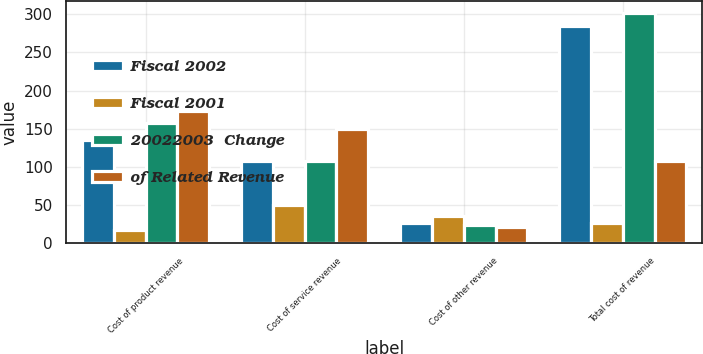Convert chart. <chart><loc_0><loc_0><loc_500><loc_500><stacked_bar_chart><ecel><fcel>Cost of product revenue<fcel>Cost of service revenue<fcel>Cost of other revenue<fcel>Total cost of revenue<nl><fcel>Fiscal 2002<fcel>135.6<fcel>108.3<fcel>26<fcel>284.8<nl><fcel>Fiscal 2001<fcel>17<fcel>50<fcel>35<fcel>26<nl><fcel>20022003  Change<fcel>157.4<fcel>107.6<fcel>24.4<fcel>301.8<nl><fcel>of Related Revenue<fcel>173.8<fcel>149.5<fcel>20.6<fcel>107.6<nl></chart> 